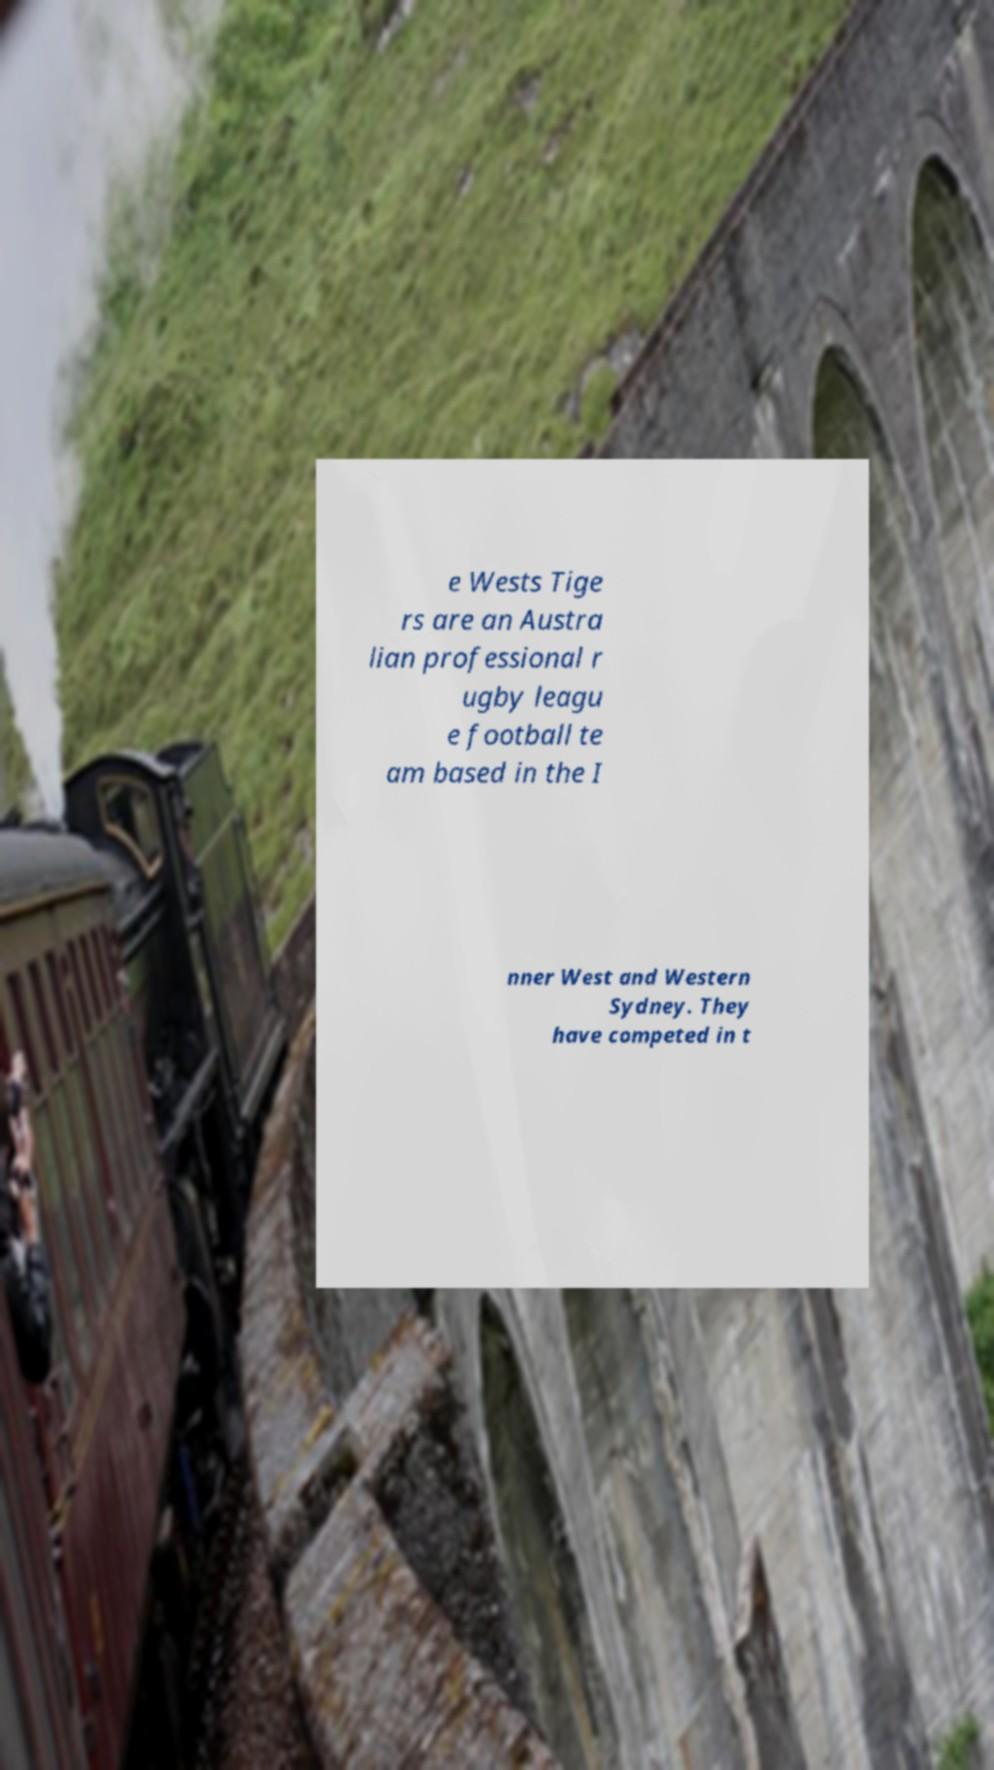There's text embedded in this image that I need extracted. Can you transcribe it verbatim? e Wests Tige rs are an Austra lian professional r ugby leagu e football te am based in the I nner West and Western Sydney. They have competed in t 